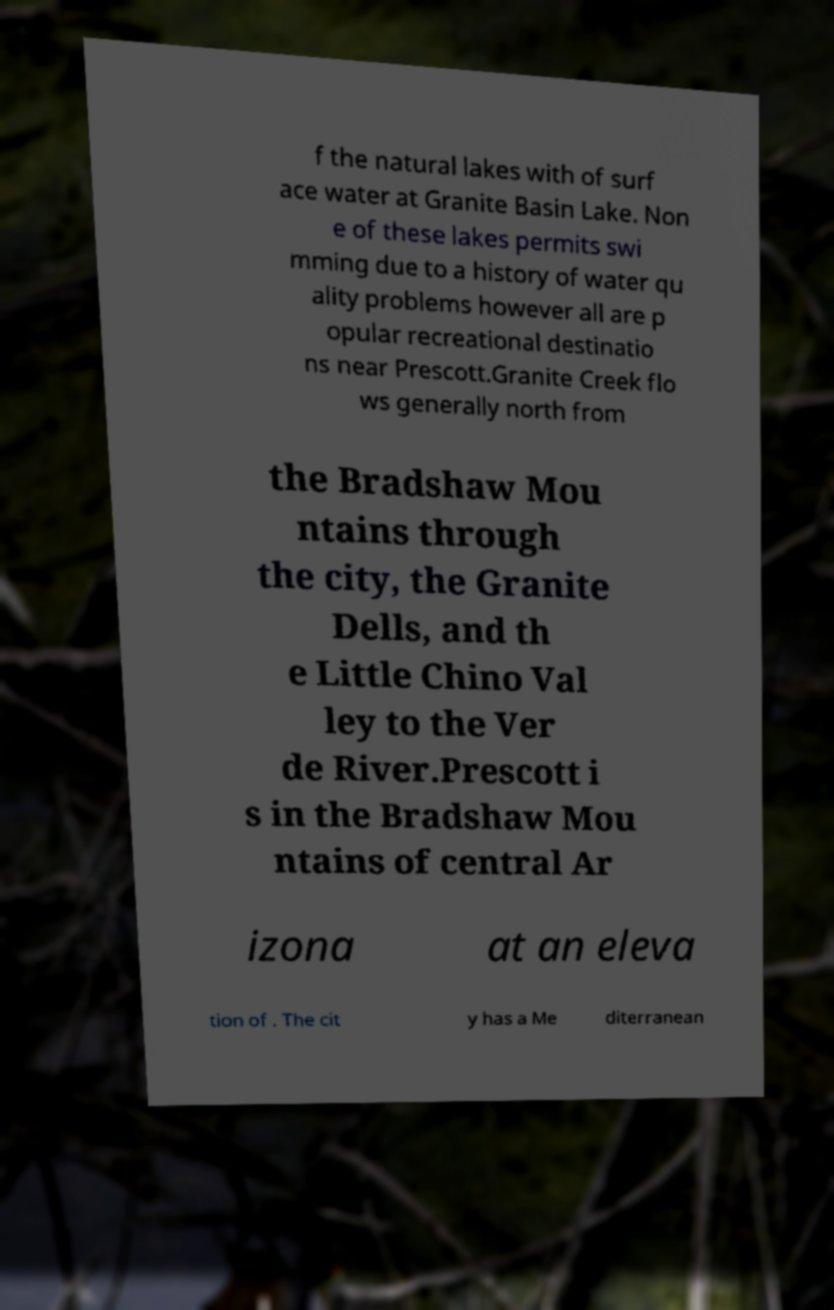Can you read and provide the text displayed in the image?This photo seems to have some interesting text. Can you extract and type it out for me? f the natural lakes with of surf ace water at Granite Basin Lake. Non e of these lakes permits swi mming due to a history of water qu ality problems however all are p opular recreational destinatio ns near Prescott.Granite Creek flo ws generally north from the Bradshaw Mou ntains through the city, the Granite Dells, and th e Little Chino Val ley to the Ver de River.Prescott i s in the Bradshaw Mou ntains of central Ar izona at an eleva tion of . The cit y has a Me diterranean 